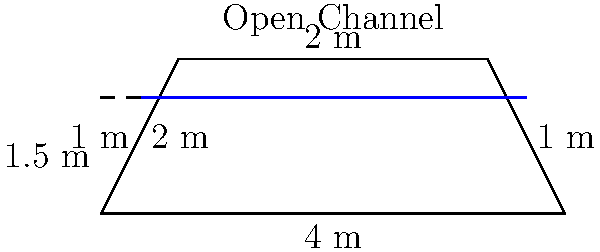Consider an open channel with a trapezoidal cross-section as shown in the figure. The bottom width is 4 m, the top width is 6 m, and the depth is 2 m. If water is flowing at a depth of 1.5 m with a mean velocity of 2 m/s, calculate the flow rate in the channel using Manning's equation. Assume the Manning's roughness coefficient $n = 0.015$ and the channel slope $S = 0.001$. Express your answer in terms of the hydraulic radius $R$. To solve this problem, we'll follow these steps:

1) First, calculate the cross-sectional area $A$ of the water flow:
   Bottom width of water = 4 m
   Top width of water = 4 + 2(1.5) = 7 m (since the side slope is 1:1)
   $A = \frac{1}{2}(4 + 7) \times 1.5 = 8.25$ m²

2) Calculate the wetted perimeter $P$:
   $P = 4 + 2\sqrt{1^2 + 1.5^2} = 4 + 2(1.8028) = 7.6056$ m

3) Calculate the hydraulic radius $R$:
   $R = \frac{A}{P} = \frac{8.25}{7.6056} = 1.0847$ m

4) Use Manning's equation to find the flow rate $Q$:
   $Q = \frac{1}{n}AR^{2/3}S^{1/2}$

   Where:
   $n = 0.015$ (given)
   $A = 8.25$ m² (calculated)
   $R = 1.0847$ m (calculated)
   $S = 0.001$ (given)

5) Substitute these values:
   $Q = \frac{1}{0.015} \times 8.25 \times (1.0847)^{2/3} \times (0.001)^{1/2}$

6) Simplify:
   $Q = 66.67 \times 8.25 \times 1.0556 \times 0.0316 = 18.44$ m³/s

7) Express in terms of $R$:
   $Q = \frac{1}{0.015} \times 8.25 \times R^{2/3} \times (0.001)^{1/2}$
   $Q = 550 \times R^{2/3}$ m³/s
Answer: $Q = 550 \times R^{2/3}$ m³/s 